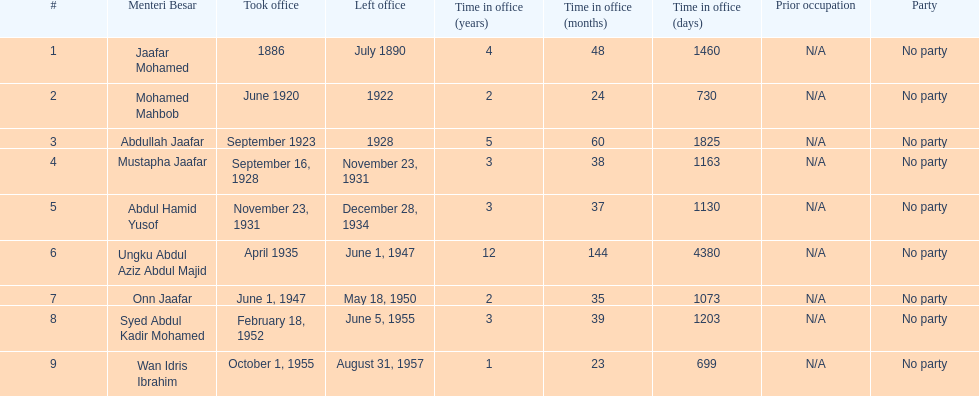Who took office after onn jaafar? Syed Abdul Kadir Mohamed. 